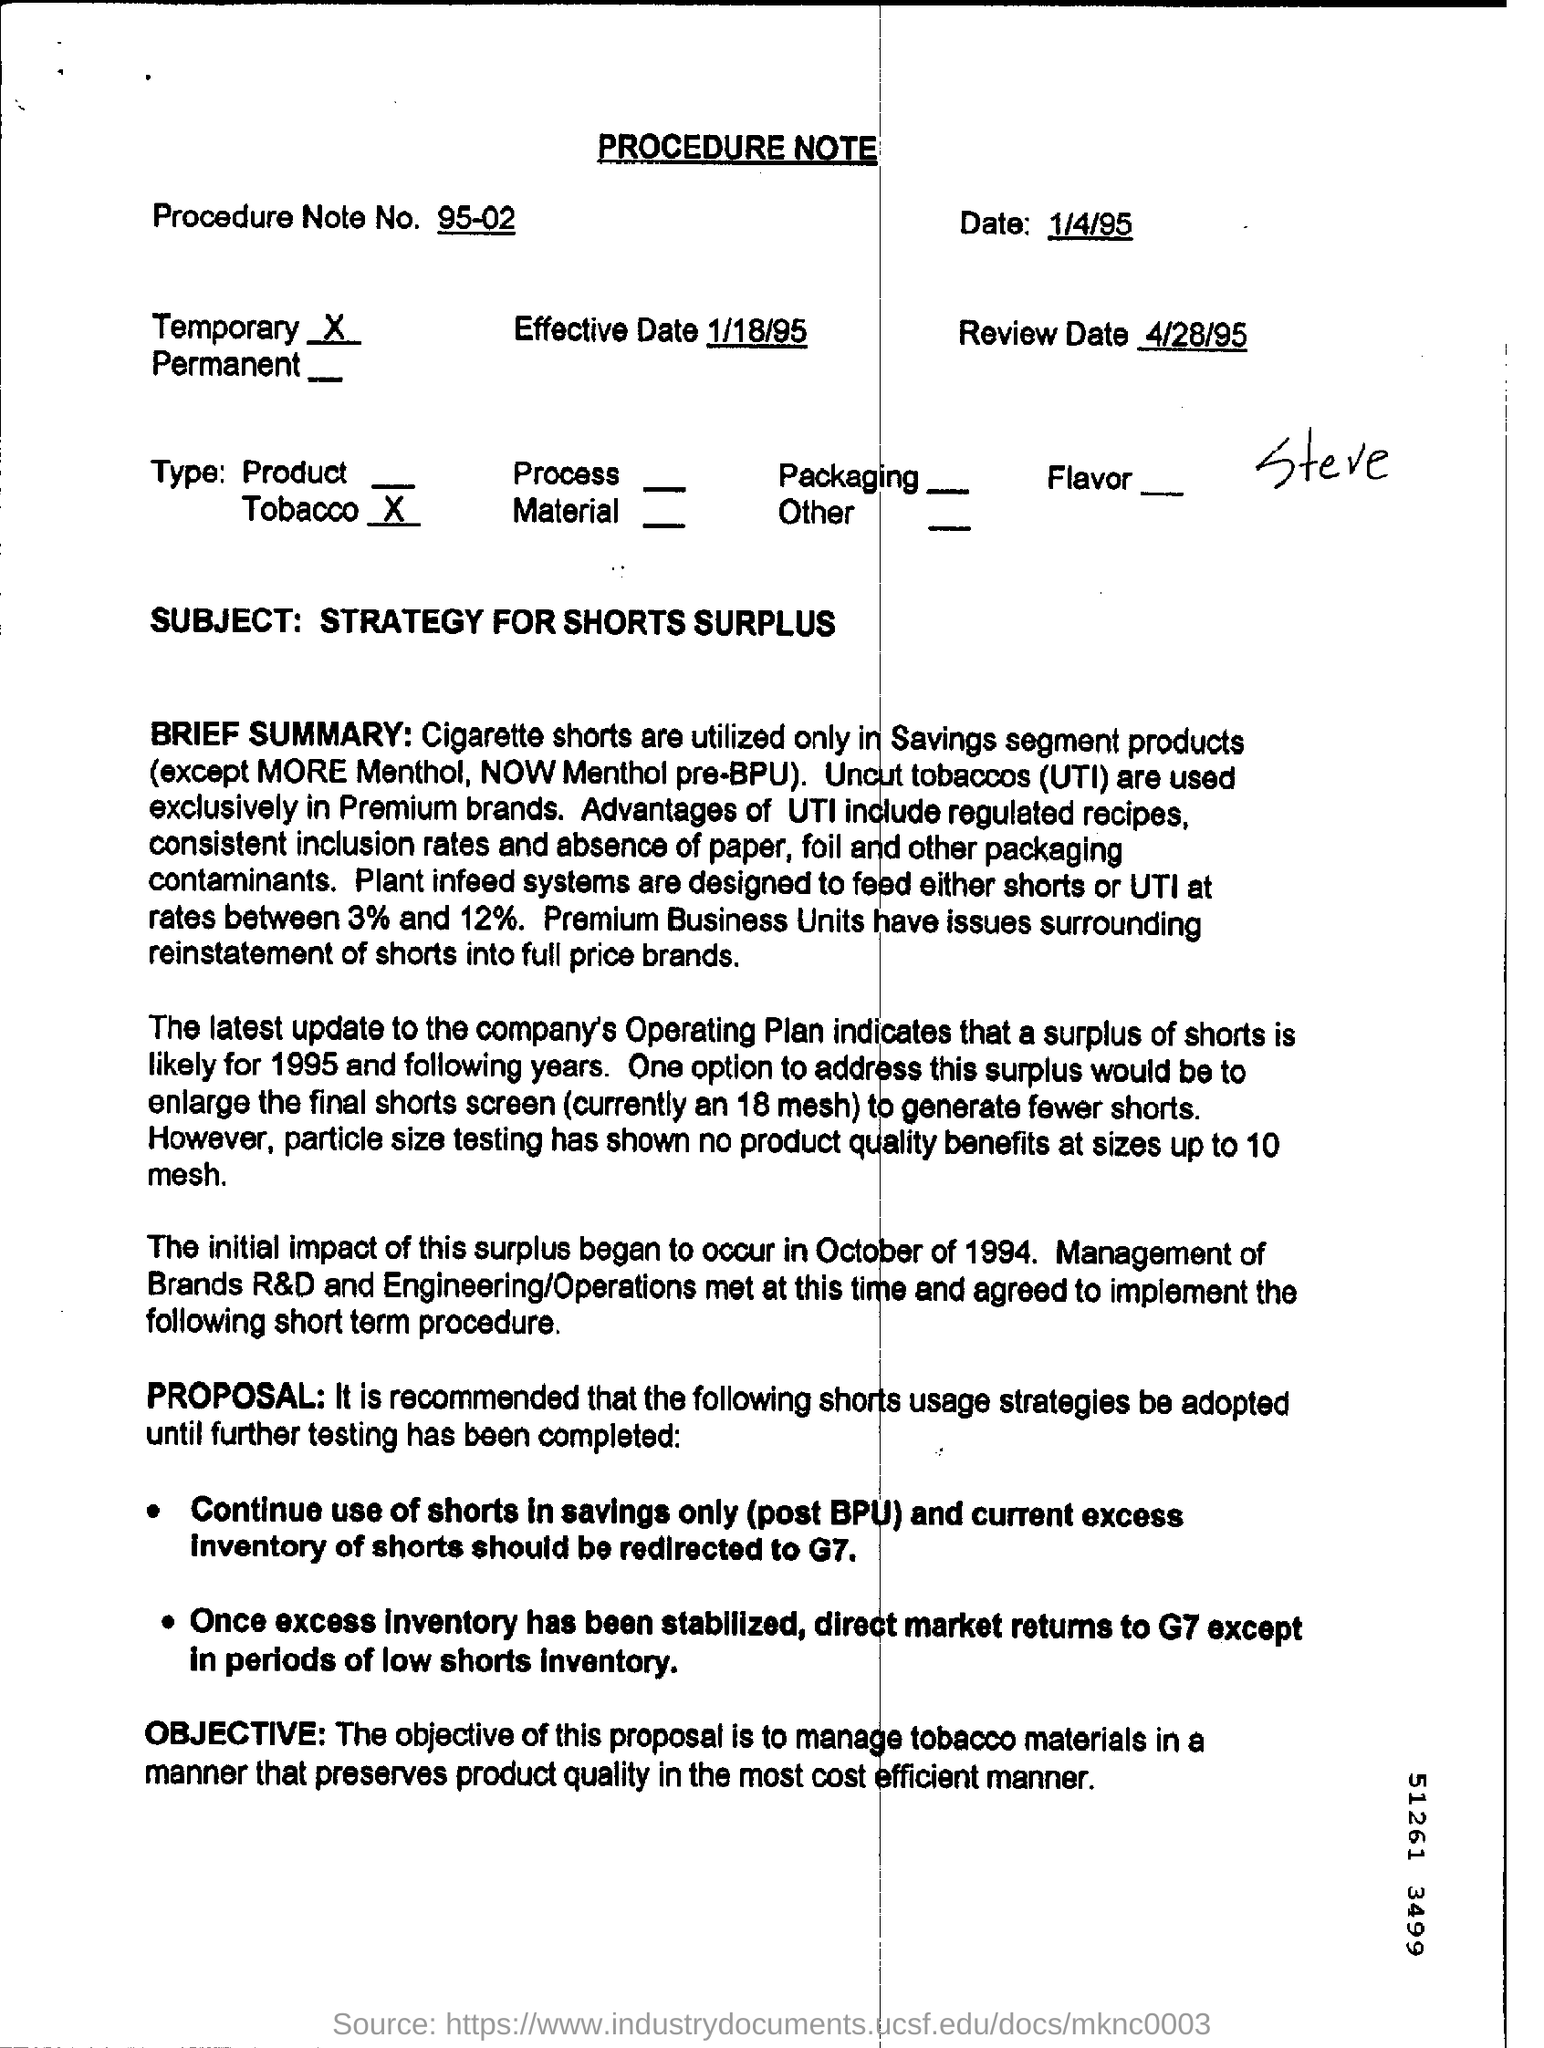What is the objective of the proposal outlined in the document? The objective of the proposal outlined in the document is to manage tobacco materials in a way that preserves product quality while being cost-efficient. 